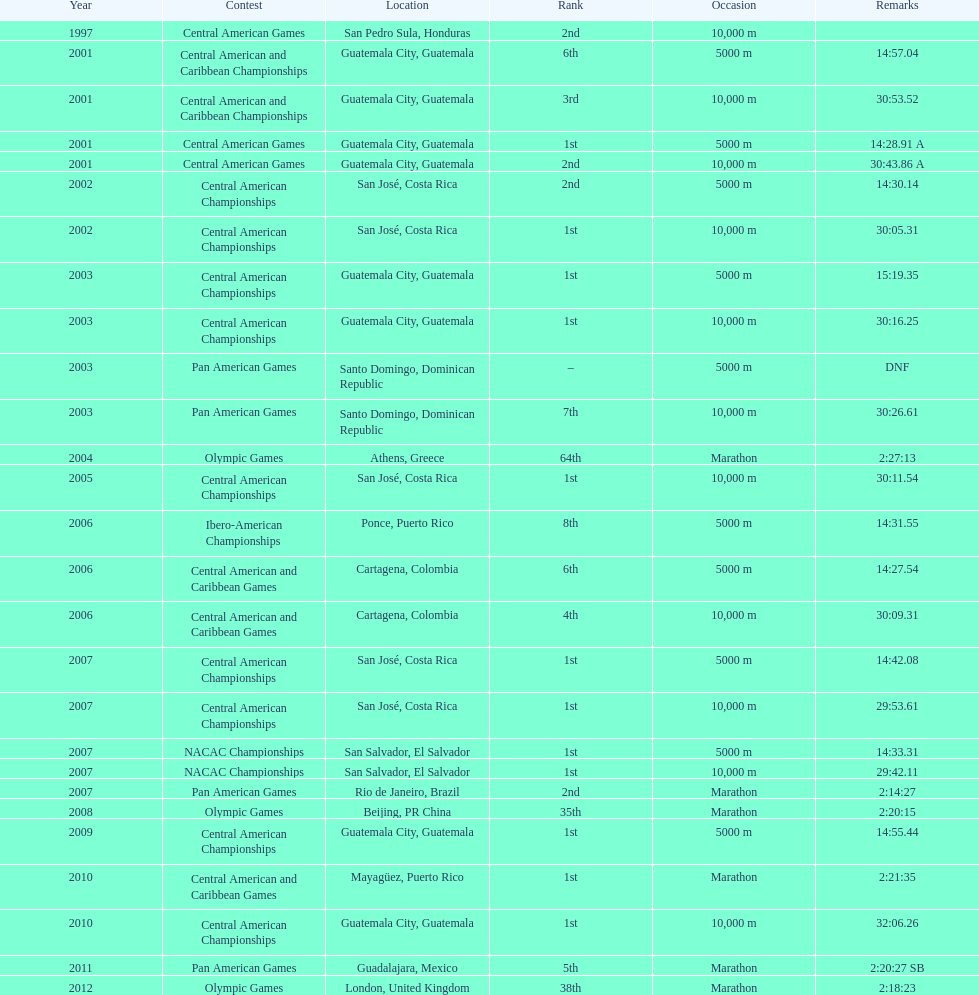Which event is listed more between the 10,000m and the 5000m? 10,000 m. 